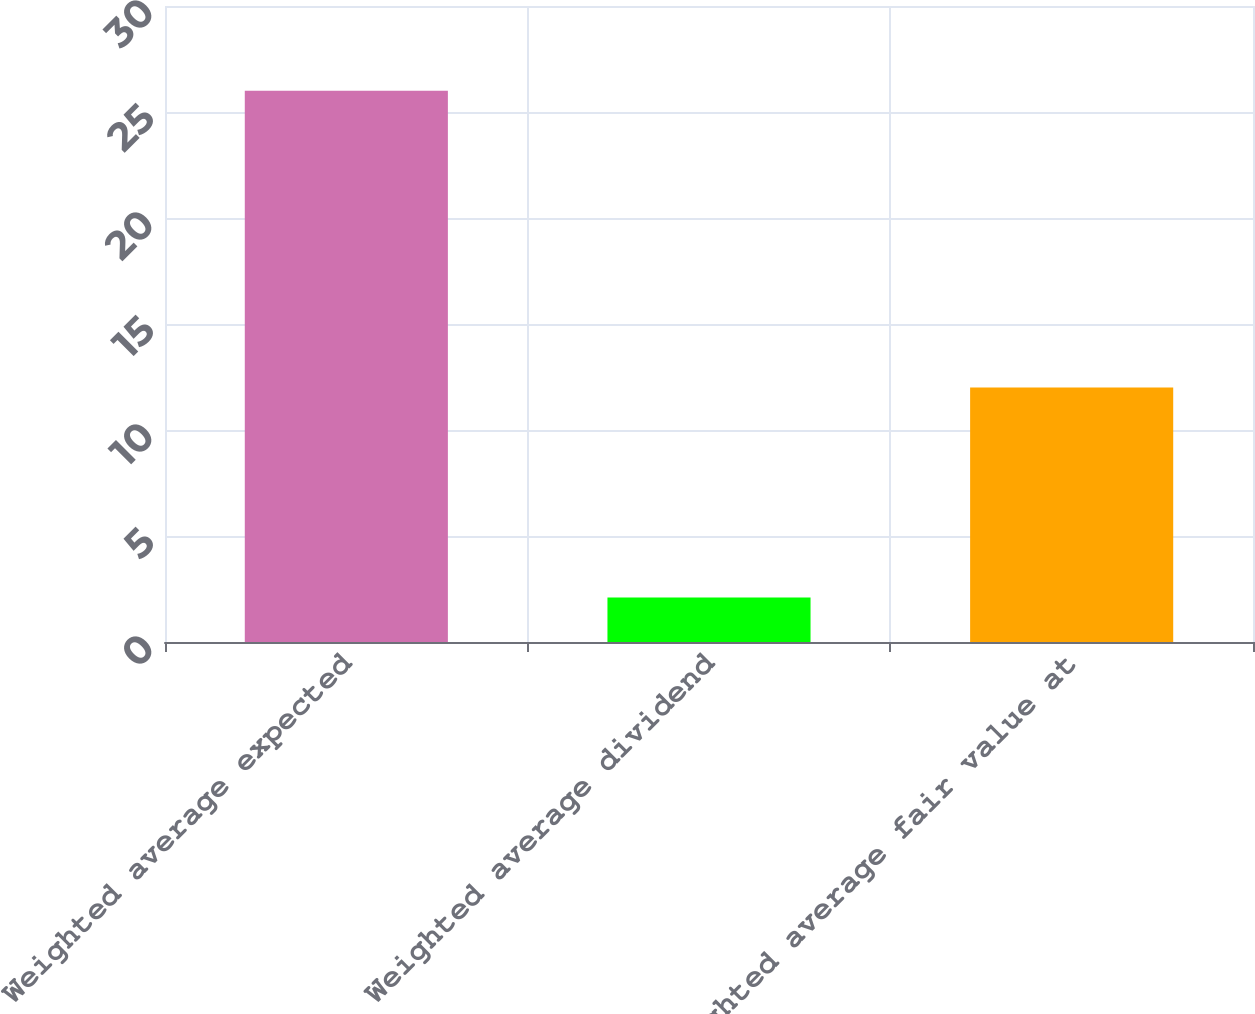Convert chart to OTSL. <chart><loc_0><loc_0><loc_500><loc_500><bar_chart><fcel>Weighted average expected<fcel>Weighted average dividend<fcel>Weighted average fair value at<nl><fcel>26<fcel>2.1<fcel>12.01<nl></chart> 